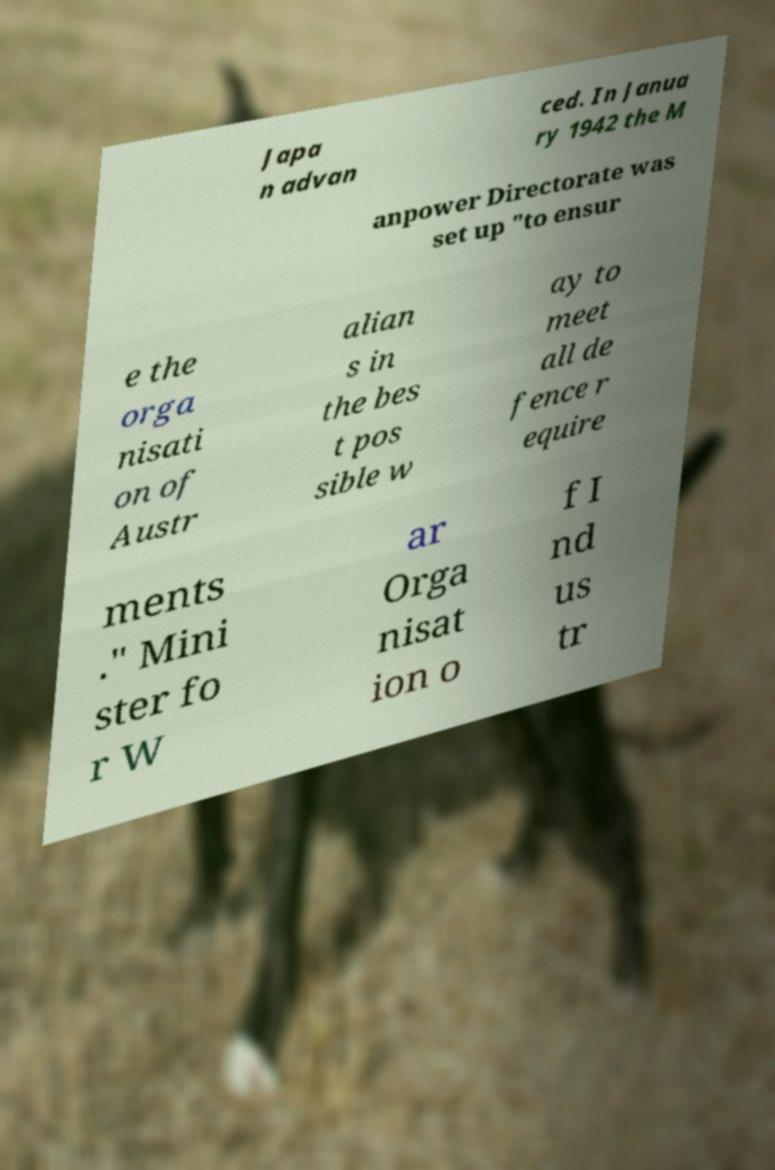Could you extract and type out the text from this image? Japa n advan ced. In Janua ry 1942 the M anpower Directorate was set up "to ensur e the orga nisati on of Austr alian s in the bes t pos sible w ay to meet all de fence r equire ments ." Mini ster fo r W ar Orga nisat ion o f I nd us tr 